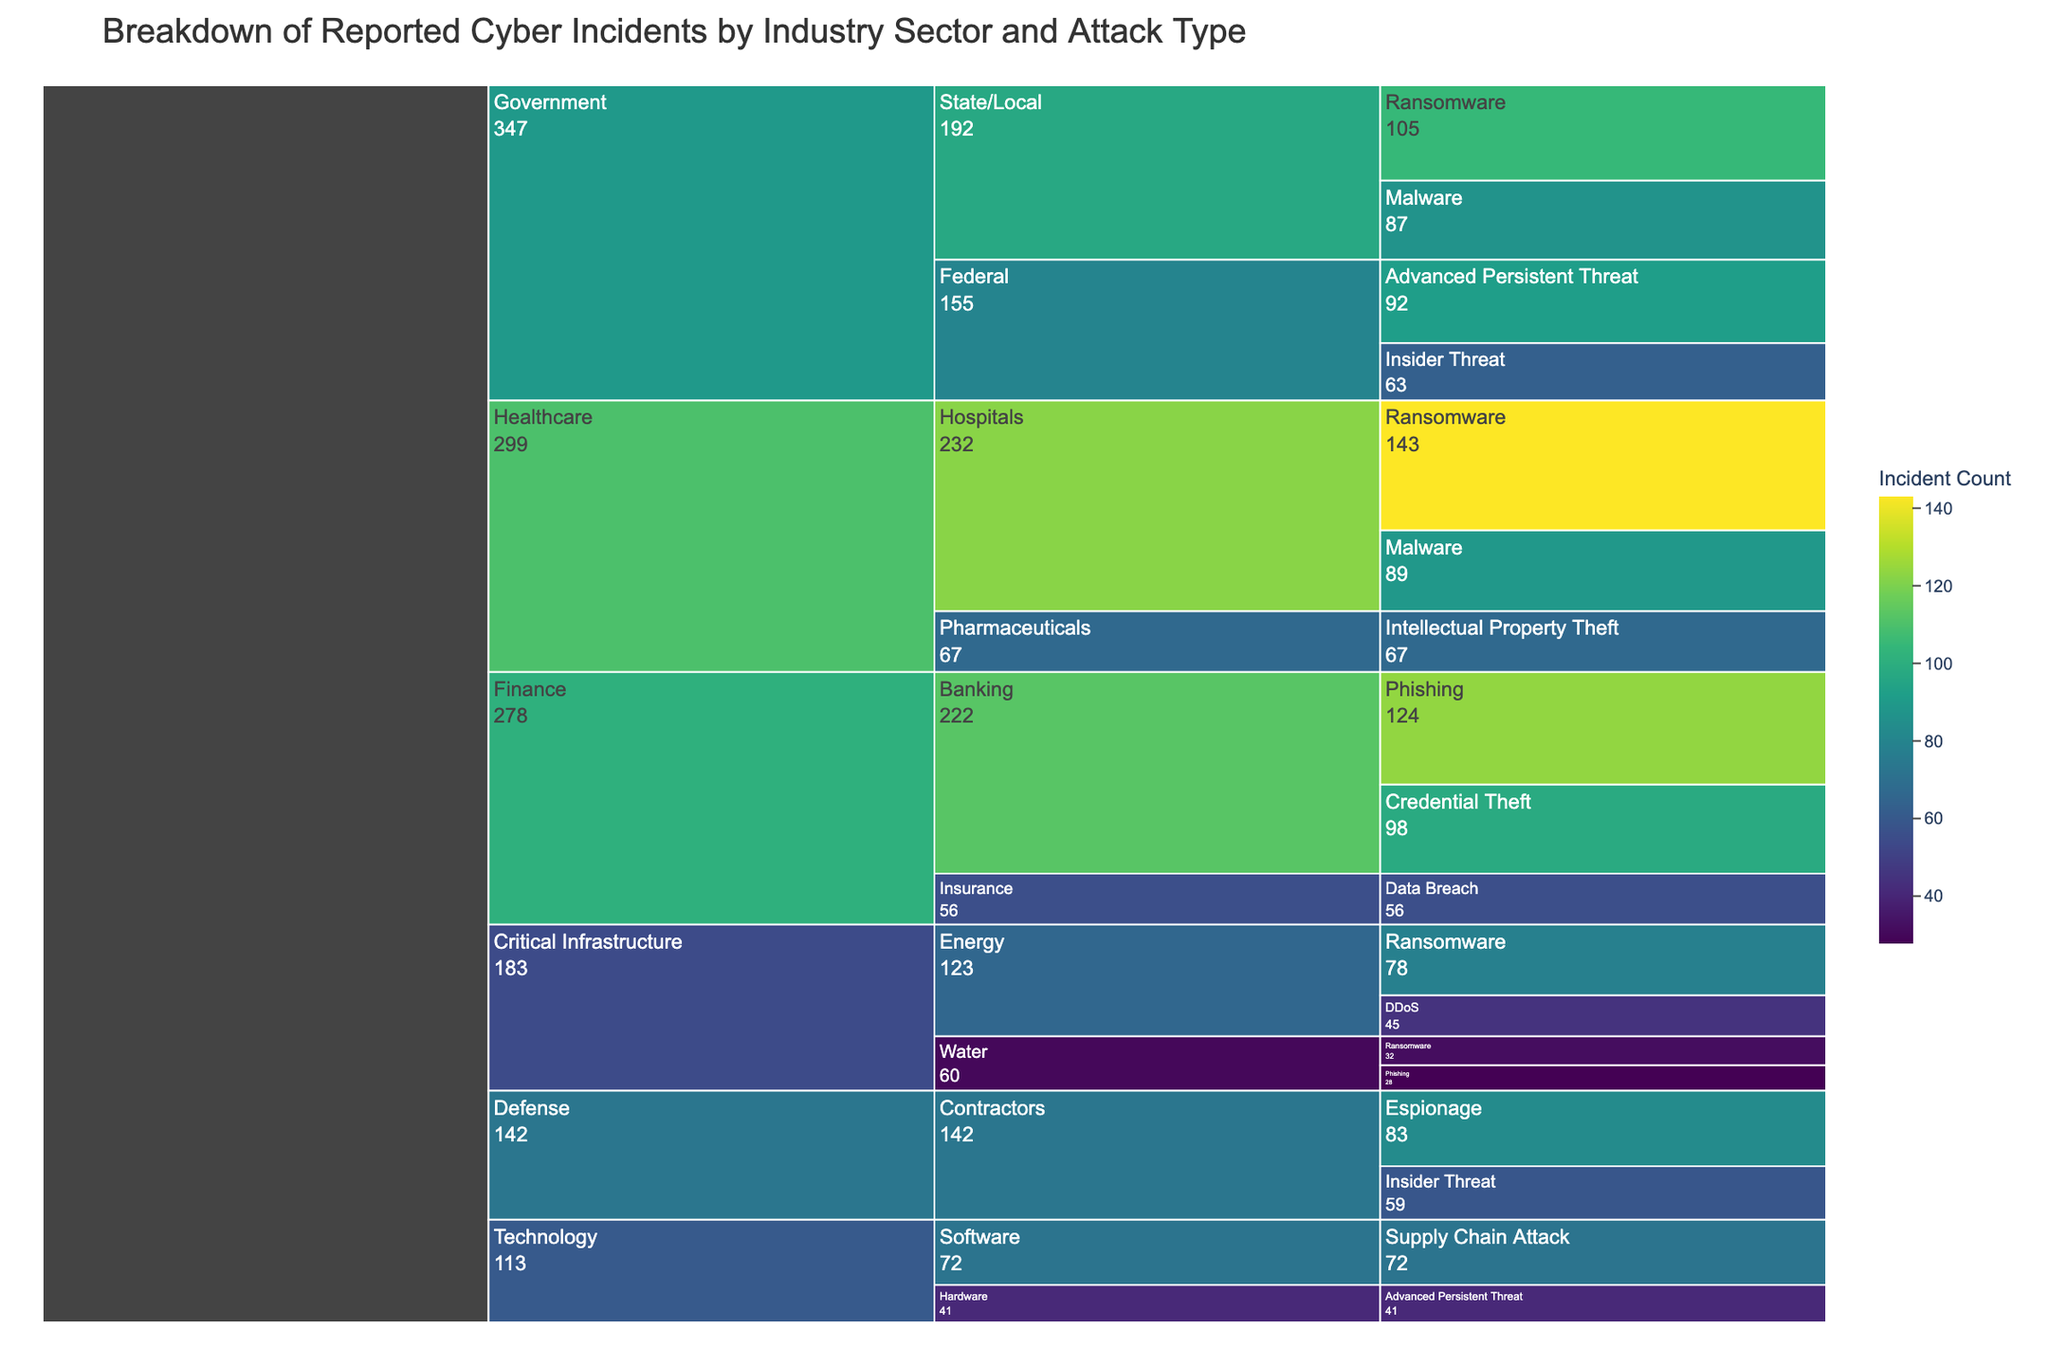What's the title of the chart? The title of the chart is displayed at the top and reads "Breakdown of Reported Cyber Incidents by Industry Sector and Attack Type."
Answer: Breakdown of Reported Cyber Incidents by Industry Sector and Attack Type Which industry has the highest number of reported cyber incidents? The industry with the highest number of reported cyber incidents can be identified by the largest segment at the top level of the chart. The Healthcare industry has a significantly large segment.
Answer: Healthcare What is the count of ransomware incidents in the Healthcare industry? Look at the section under the Healthcare industry and locate the segment labeled 'Ransomware'. The count value is specified within that segment.
Answer: 143 How does the number of phishing incidents in the Finance industry compare to the total insider threats in the Government sector? Locate the segments for 'Phishing' under 'Finance' and 'Insider Threat' under 'Government'. The counts are 124 and 122 respectively. Compare these values.
Answer: Phishing in Finance: 124, Insider Threat in Government: 122 What is the most common attack type in the Energy sector? Within the Critical Infrastructure -> Energy path, identify the attack type segment with the highest count value.
Answer: Ransomware What is the total count of cyber incidents in the State/Local Government? Look under Government -> State/Local and sum the counts of all attack types listed. The segments list 'Ransomware' with 105 and 'Malware' with 87. Add these values.
Answer: 192 Which sector under the Critical Infrastructure industry has fewer ransomware incidents, Energy or Water? Compare the ransomware segment counts under Energy (78) and Water (32) within Critical Infrastructure.
Answer: Water In the Defense industry, what is the difference in the number of incidents between Espionage and Insider Threat? Locate the segments for 'Espionage' and 'Insider Threat' under Defense. Subtract the count of Insider Threat (59) from Espionage (83).
Answer: 24 What are the different attack types reported in the Technology sector? Observe the segments under Technology to list all attack types. They are listed as 'Supply Chain Attack' and 'Advanced Persistent Threat'.
Answer: Supply Chain Attack, Advanced Persistent Threat Which industry has more advanced persistent threat incidents, Government or Technology? Compare the count values of the 'Advanced Persistent Threat' segments under Government (92) and Technology (41).
Answer: Government 